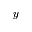Convert formula to latex. <formula><loc_0><loc_0><loc_500><loc_500>y</formula> 